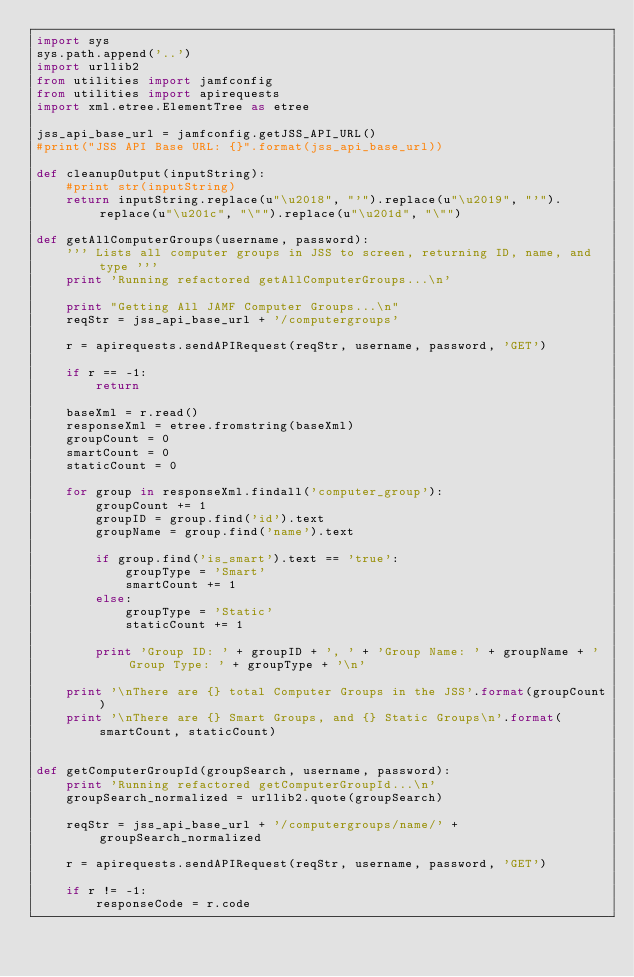Convert code to text. <code><loc_0><loc_0><loc_500><loc_500><_Python_>import sys
sys.path.append('..')
import urllib2
from utilities import jamfconfig
from utilities import apirequests
import xml.etree.ElementTree as etree

jss_api_base_url = jamfconfig.getJSS_API_URL()
#print("JSS API Base URL: {}".format(jss_api_base_url))

def cleanupOutput(inputString):
    #print str(inputString)
    return inputString.replace(u"\u2018", "'").replace(u"\u2019", "'").replace(u"\u201c", "\"").replace(u"\u201d", "\"")

def getAllComputerGroups(username, password):
    ''' Lists all computer groups in JSS to screen, returning ID, name, and type '''
    print 'Running refactored getAllComputerGroups...\n'

    print "Getting All JAMF Computer Groups...\n"
    reqStr = jss_api_base_url + '/computergroups'

    r = apirequests.sendAPIRequest(reqStr, username, password, 'GET')

    if r == -1:
        return

    baseXml = r.read()
    responseXml = etree.fromstring(baseXml)
    groupCount = 0
    smartCount = 0
    staticCount = 0

    for group in responseXml.findall('computer_group'):
        groupCount += 1
        groupID = group.find('id').text
        groupName = group.find('name').text

        if group.find('is_smart').text == 'true':
            groupType = 'Smart'
            smartCount += 1
        else:
            groupType = 'Static'
            staticCount += 1

        print 'Group ID: ' + groupID + ', ' + 'Group Name: ' + groupName + 'Group Type: ' + groupType + '\n'

    print '\nThere are {} total Computer Groups in the JSS'.format(groupCount)
    print '\nThere are {} Smart Groups, and {} Static Groups\n'.format(smartCount, staticCount)


def getComputerGroupId(groupSearch, username, password):
    print 'Running refactored getComputerGroupId...\n'
    groupSearch_normalized = urllib2.quote(groupSearch)

    reqStr = jss_api_base_url + '/computergroups/name/' + groupSearch_normalized

    r = apirequests.sendAPIRequest(reqStr, username, password, 'GET')

    if r != -1:
        responseCode = r.code</code> 